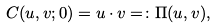<formula> <loc_0><loc_0><loc_500><loc_500>C ( u , v ; 0 ) = u \cdot v = \colon \Pi ( u , v ) ,</formula> 